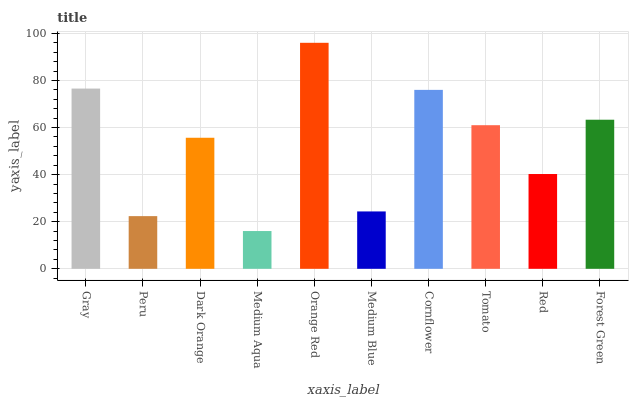Is Peru the minimum?
Answer yes or no. No. Is Peru the maximum?
Answer yes or no. No. Is Gray greater than Peru?
Answer yes or no. Yes. Is Peru less than Gray?
Answer yes or no. Yes. Is Peru greater than Gray?
Answer yes or no. No. Is Gray less than Peru?
Answer yes or no. No. Is Tomato the high median?
Answer yes or no. Yes. Is Dark Orange the low median?
Answer yes or no. Yes. Is Medium Blue the high median?
Answer yes or no. No. Is Cornflower the low median?
Answer yes or no. No. 